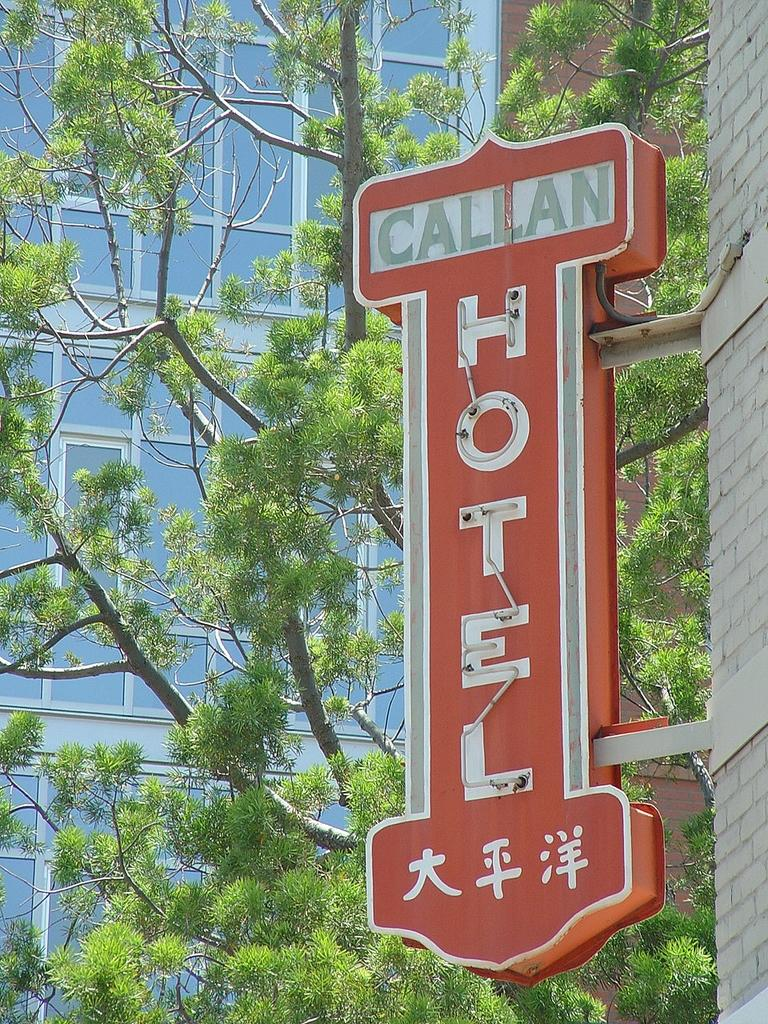What is the color of the board in the image? The board in the image is red. What type of natural element can be seen in the image? There is a tree in the image. What type of structure is located on the left side of the image? There is a glass building on the left side of the image. What kind of list can be seen hanging from the tree in the image? There is no list present in the image; it features a red-colored board, a tree, and a glass building. How does the rainstorm affect the glass building in the image? There is no rainstorm present in the image; it is a clear day with a tree, a red-colored board, and a glass building. 